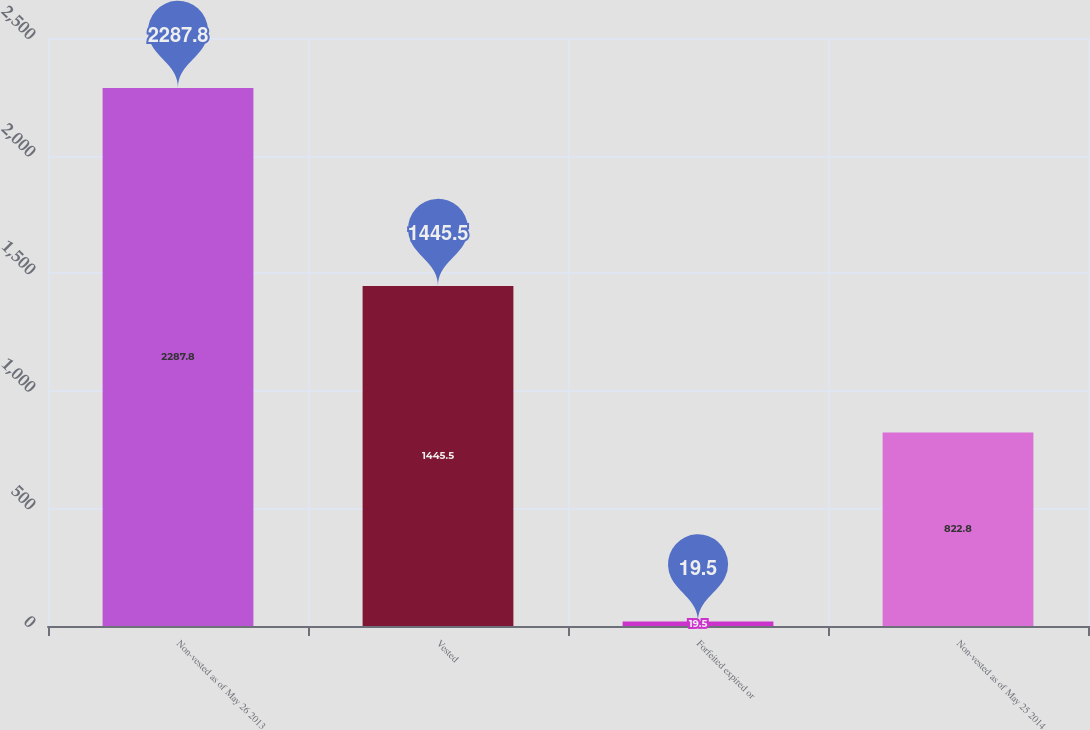Convert chart. <chart><loc_0><loc_0><loc_500><loc_500><bar_chart><fcel>Non-vested as of May 26 2013<fcel>Vested<fcel>Forfeited expired or<fcel>Non-vested as of May 25 2014<nl><fcel>2287.8<fcel>1445.5<fcel>19.5<fcel>822.8<nl></chart> 